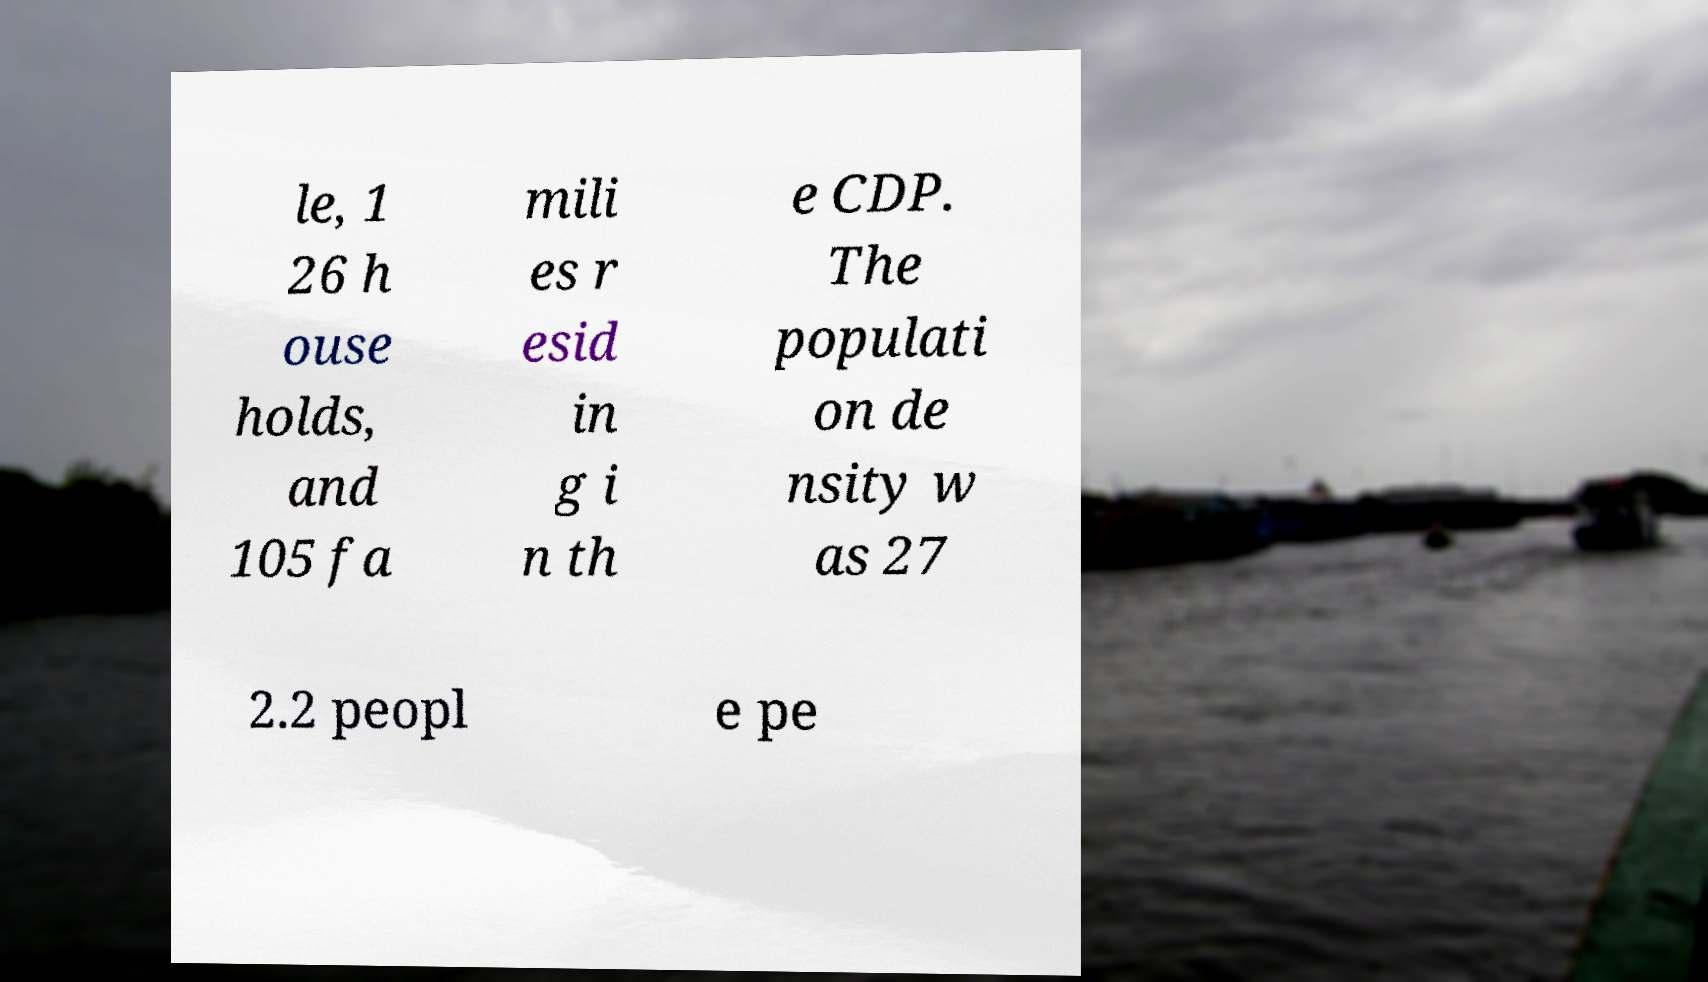Can you read and provide the text displayed in the image?This photo seems to have some interesting text. Can you extract and type it out for me? le, 1 26 h ouse holds, and 105 fa mili es r esid in g i n th e CDP. The populati on de nsity w as 27 2.2 peopl e pe 